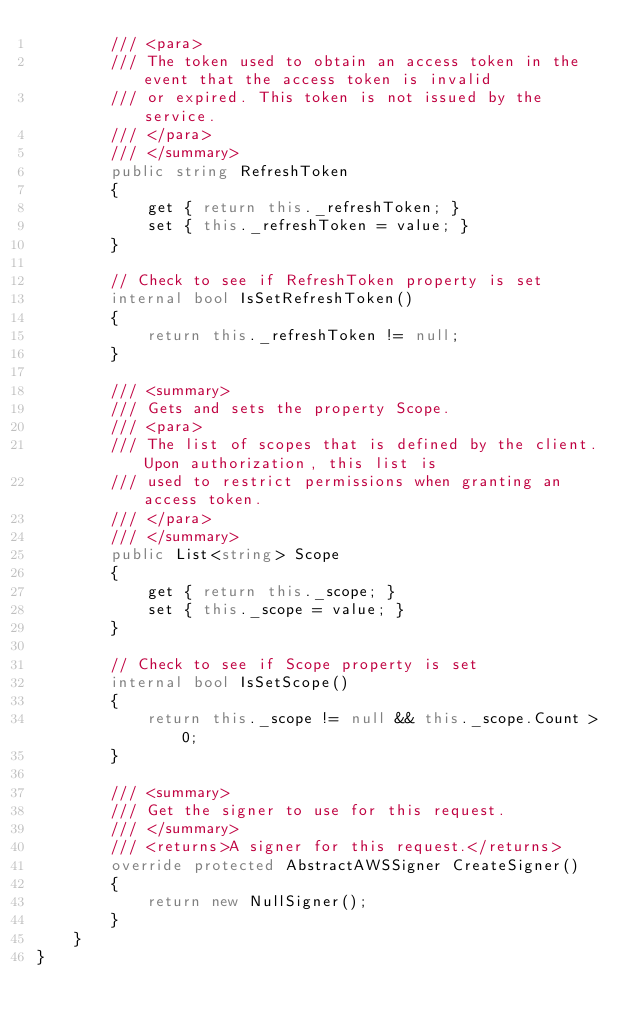Convert code to text. <code><loc_0><loc_0><loc_500><loc_500><_C#_>        /// <para>
        /// The token used to obtain an access token in the event that the access token is invalid
        /// or expired. This token is not issued by the service.
        /// </para>
        /// </summary>
        public string RefreshToken
        {
            get { return this._refreshToken; }
            set { this._refreshToken = value; }
        }

        // Check to see if RefreshToken property is set
        internal bool IsSetRefreshToken()
        {
            return this._refreshToken != null;
        }

        /// <summary>
        /// Gets and sets the property Scope. 
        /// <para>
        /// The list of scopes that is defined by the client. Upon authorization, this list is
        /// used to restrict permissions when granting an access token.
        /// </para>
        /// </summary>
        public List<string> Scope
        {
            get { return this._scope; }
            set { this._scope = value; }
        }

        // Check to see if Scope property is set
        internal bool IsSetScope()
        {
            return this._scope != null && this._scope.Count > 0; 
        }

        /// <summary>
        /// Get the signer to use for this request.
        /// </summary>
        /// <returns>A signer for this request.</returns>
        override protected AbstractAWSSigner CreateSigner()
        {
            return new NullSigner();
        }
    }
}</code> 